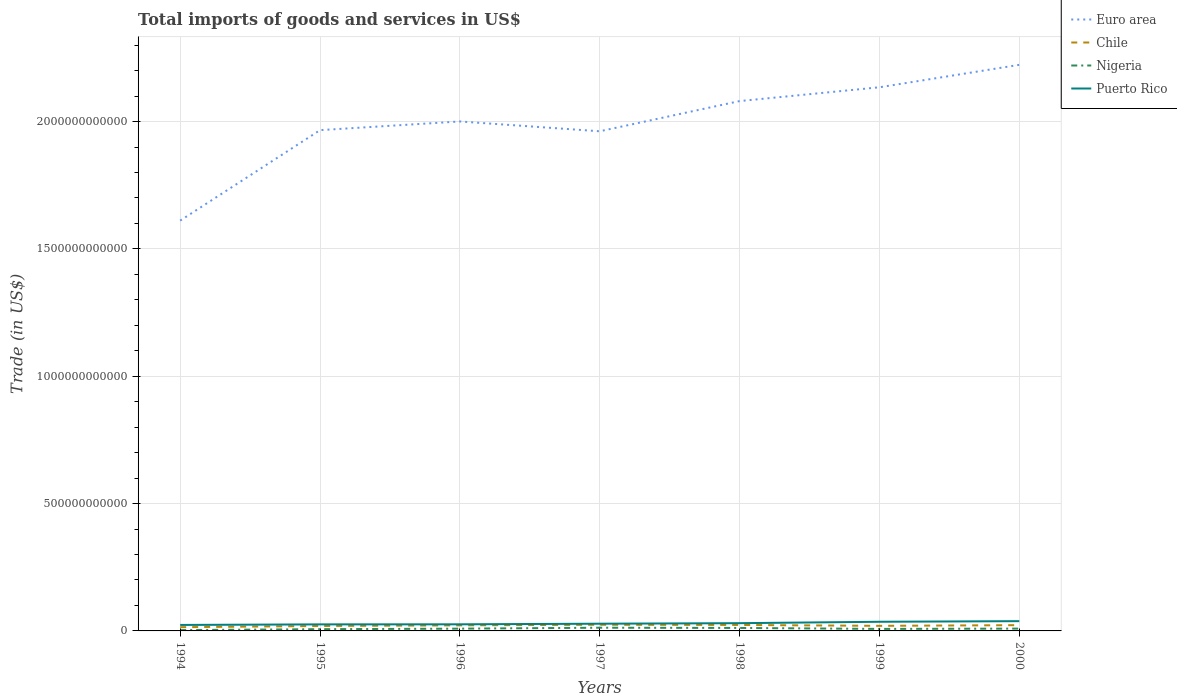Does the line corresponding to Euro area intersect with the line corresponding to Chile?
Ensure brevity in your answer.  No. Is the number of lines equal to the number of legend labels?
Your answer should be very brief. Yes. Across all years, what is the maximum total imports of goods and services in Puerto Rico?
Your answer should be very brief. 2.35e+1. What is the total total imports of goods and services in Nigeria in the graph?
Your answer should be compact. -5.72e+09. What is the difference between the highest and the second highest total imports of goods and services in Nigeria?
Give a very brief answer. 9.31e+09. How many years are there in the graph?
Keep it short and to the point. 7. What is the difference between two consecutive major ticks on the Y-axis?
Offer a very short reply. 5.00e+11. Does the graph contain any zero values?
Provide a succinct answer. No. Where does the legend appear in the graph?
Offer a terse response. Top right. How are the legend labels stacked?
Your answer should be very brief. Vertical. What is the title of the graph?
Offer a terse response. Total imports of goods and services in US$. Does "Uzbekistan" appear as one of the legend labels in the graph?
Offer a terse response. No. What is the label or title of the X-axis?
Ensure brevity in your answer.  Years. What is the label or title of the Y-axis?
Your answer should be very brief. Trade (in US$). What is the Trade (in US$) in Euro area in 1994?
Your response must be concise. 1.61e+12. What is the Trade (in US$) of Chile in 1994?
Give a very brief answer. 1.47e+1. What is the Trade (in US$) of Nigeria in 1994?
Offer a very short reply. 3.26e+09. What is the Trade (in US$) of Puerto Rico in 1994?
Make the answer very short. 2.35e+1. What is the Trade (in US$) in Euro area in 1995?
Offer a very short reply. 1.97e+12. What is the Trade (in US$) of Chile in 1995?
Offer a very short reply. 1.93e+1. What is the Trade (in US$) in Nigeria in 1995?
Provide a short and direct response. 6.85e+09. What is the Trade (in US$) in Puerto Rico in 1995?
Keep it short and to the point. 2.57e+1. What is the Trade (in US$) in Euro area in 1996?
Your response must be concise. 2.00e+12. What is the Trade (in US$) in Chile in 1996?
Keep it short and to the point. 2.19e+1. What is the Trade (in US$) of Nigeria in 1996?
Offer a very short reply. 8.91e+09. What is the Trade (in US$) in Puerto Rico in 1996?
Offer a very short reply. 2.60e+1. What is the Trade (in US$) in Euro area in 1997?
Ensure brevity in your answer.  1.96e+12. What is the Trade (in US$) in Chile in 1997?
Provide a short and direct response. 2.42e+1. What is the Trade (in US$) of Nigeria in 1997?
Your answer should be very brief. 1.26e+1. What is the Trade (in US$) of Puerto Rico in 1997?
Keep it short and to the point. 2.83e+1. What is the Trade (in US$) of Euro area in 1998?
Offer a terse response. 2.08e+12. What is the Trade (in US$) of Chile in 1998?
Make the answer very short. 2.35e+1. What is the Trade (in US$) of Nigeria in 1998?
Offer a very short reply. 1.17e+1. What is the Trade (in US$) of Puerto Rico in 1998?
Your answer should be very brief. 3.04e+1. What is the Trade (in US$) of Euro area in 1999?
Provide a succinct answer. 2.13e+12. What is the Trade (in US$) of Chile in 1999?
Your answer should be very brief. 1.99e+1. What is the Trade (in US$) of Nigeria in 1999?
Your answer should be compact. 7.88e+09. What is the Trade (in US$) of Puerto Rico in 1999?
Ensure brevity in your answer.  3.59e+1. What is the Trade (in US$) of Euro area in 2000?
Your answer should be very brief. 2.22e+12. What is the Trade (in US$) in Chile in 2000?
Provide a succinct answer. 2.27e+1. What is the Trade (in US$) of Nigeria in 2000?
Offer a very short reply. 9.11e+09. What is the Trade (in US$) in Puerto Rico in 2000?
Your answer should be very brief. 3.83e+1. Across all years, what is the maximum Trade (in US$) of Euro area?
Offer a terse response. 2.22e+12. Across all years, what is the maximum Trade (in US$) of Chile?
Your answer should be very brief. 2.42e+1. Across all years, what is the maximum Trade (in US$) in Nigeria?
Make the answer very short. 1.26e+1. Across all years, what is the maximum Trade (in US$) of Puerto Rico?
Your answer should be compact. 3.83e+1. Across all years, what is the minimum Trade (in US$) of Euro area?
Keep it short and to the point. 1.61e+12. Across all years, what is the minimum Trade (in US$) in Chile?
Your answer should be very brief. 1.47e+1. Across all years, what is the minimum Trade (in US$) of Nigeria?
Offer a terse response. 3.26e+09. Across all years, what is the minimum Trade (in US$) in Puerto Rico?
Make the answer very short. 2.35e+1. What is the total Trade (in US$) of Euro area in the graph?
Your answer should be compact. 1.40e+13. What is the total Trade (in US$) in Chile in the graph?
Provide a short and direct response. 1.46e+11. What is the total Trade (in US$) in Nigeria in the graph?
Keep it short and to the point. 6.03e+1. What is the total Trade (in US$) in Puerto Rico in the graph?
Offer a very short reply. 2.08e+11. What is the difference between the Trade (in US$) in Euro area in 1994 and that in 1995?
Provide a succinct answer. -3.55e+11. What is the difference between the Trade (in US$) in Chile in 1994 and that in 1995?
Your answer should be compact. -4.68e+09. What is the difference between the Trade (in US$) in Nigeria in 1994 and that in 1995?
Offer a very short reply. -3.60e+09. What is the difference between the Trade (in US$) in Puerto Rico in 1994 and that in 1995?
Provide a succinct answer. -2.20e+09. What is the difference between the Trade (in US$) in Euro area in 1994 and that in 1996?
Your answer should be compact. -3.89e+11. What is the difference between the Trade (in US$) in Chile in 1994 and that in 1996?
Your answer should be compact. -7.29e+09. What is the difference between the Trade (in US$) in Nigeria in 1994 and that in 1996?
Offer a terse response. -5.65e+09. What is the difference between the Trade (in US$) in Puerto Rico in 1994 and that in 1996?
Ensure brevity in your answer.  -2.47e+09. What is the difference between the Trade (in US$) of Euro area in 1994 and that in 1997?
Give a very brief answer. -3.51e+11. What is the difference between the Trade (in US$) in Chile in 1994 and that in 1997?
Your answer should be very brief. -9.53e+09. What is the difference between the Trade (in US$) of Nigeria in 1994 and that in 1997?
Provide a succinct answer. -9.31e+09. What is the difference between the Trade (in US$) of Puerto Rico in 1994 and that in 1997?
Your answer should be compact. -4.81e+09. What is the difference between the Trade (in US$) of Euro area in 1994 and that in 1998?
Offer a terse response. -4.69e+11. What is the difference between the Trade (in US$) in Chile in 1994 and that in 1998?
Provide a short and direct response. -8.81e+09. What is the difference between the Trade (in US$) of Nigeria in 1994 and that in 1998?
Offer a terse response. -8.42e+09. What is the difference between the Trade (in US$) in Puerto Rico in 1994 and that in 1998?
Your response must be concise. -6.94e+09. What is the difference between the Trade (in US$) of Euro area in 1994 and that in 1999?
Your response must be concise. -5.24e+11. What is the difference between the Trade (in US$) in Chile in 1994 and that in 1999?
Give a very brief answer. -5.29e+09. What is the difference between the Trade (in US$) of Nigeria in 1994 and that in 1999?
Keep it short and to the point. -4.63e+09. What is the difference between the Trade (in US$) of Puerto Rico in 1994 and that in 1999?
Make the answer very short. -1.24e+1. What is the difference between the Trade (in US$) of Euro area in 1994 and that in 2000?
Give a very brief answer. -6.12e+11. What is the difference between the Trade (in US$) of Chile in 1994 and that in 2000?
Make the answer very short. -8.01e+09. What is the difference between the Trade (in US$) in Nigeria in 1994 and that in 2000?
Make the answer very short. -5.86e+09. What is the difference between the Trade (in US$) of Puerto Rico in 1994 and that in 2000?
Your answer should be very brief. -1.48e+1. What is the difference between the Trade (in US$) of Euro area in 1995 and that in 1996?
Your answer should be compact. -3.41e+1. What is the difference between the Trade (in US$) of Chile in 1995 and that in 1996?
Ensure brevity in your answer.  -2.61e+09. What is the difference between the Trade (in US$) in Nigeria in 1995 and that in 1996?
Your answer should be compact. -2.05e+09. What is the difference between the Trade (in US$) of Puerto Rico in 1995 and that in 1996?
Provide a succinct answer. -2.71e+08. What is the difference between the Trade (in US$) in Euro area in 1995 and that in 1997?
Give a very brief answer. 4.49e+09. What is the difference between the Trade (in US$) of Chile in 1995 and that in 1997?
Your answer should be compact. -4.85e+09. What is the difference between the Trade (in US$) of Nigeria in 1995 and that in 1997?
Make the answer very short. -5.72e+09. What is the difference between the Trade (in US$) in Puerto Rico in 1995 and that in 1997?
Your answer should be compact. -2.62e+09. What is the difference between the Trade (in US$) of Euro area in 1995 and that in 1998?
Provide a short and direct response. -1.14e+11. What is the difference between the Trade (in US$) of Chile in 1995 and that in 1998?
Your answer should be compact. -4.13e+09. What is the difference between the Trade (in US$) of Nigeria in 1995 and that in 1998?
Provide a short and direct response. -4.82e+09. What is the difference between the Trade (in US$) of Puerto Rico in 1995 and that in 1998?
Your answer should be very brief. -4.74e+09. What is the difference between the Trade (in US$) of Euro area in 1995 and that in 1999?
Your answer should be very brief. -1.68e+11. What is the difference between the Trade (in US$) in Chile in 1995 and that in 1999?
Offer a very short reply. -6.09e+08. What is the difference between the Trade (in US$) in Nigeria in 1995 and that in 1999?
Make the answer very short. -1.03e+09. What is the difference between the Trade (in US$) of Puerto Rico in 1995 and that in 1999?
Offer a terse response. -1.02e+1. What is the difference between the Trade (in US$) of Euro area in 1995 and that in 2000?
Provide a short and direct response. -2.56e+11. What is the difference between the Trade (in US$) of Chile in 1995 and that in 2000?
Your answer should be very brief. -3.33e+09. What is the difference between the Trade (in US$) in Nigeria in 1995 and that in 2000?
Provide a short and direct response. -2.26e+09. What is the difference between the Trade (in US$) in Puerto Rico in 1995 and that in 2000?
Make the answer very short. -1.26e+1. What is the difference between the Trade (in US$) in Euro area in 1996 and that in 1997?
Provide a succinct answer. 3.86e+1. What is the difference between the Trade (in US$) of Chile in 1996 and that in 1997?
Your answer should be compact. -2.24e+09. What is the difference between the Trade (in US$) in Nigeria in 1996 and that in 1997?
Offer a very short reply. -3.66e+09. What is the difference between the Trade (in US$) in Puerto Rico in 1996 and that in 1997?
Offer a terse response. -2.34e+09. What is the difference between the Trade (in US$) in Euro area in 1996 and that in 1998?
Give a very brief answer. -8.00e+1. What is the difference between the Trade (in US$) of Chile in 1996 and that in 1998?
Ensure brevity in your answer.  -1.52e+09. What is the difference between the Trade (in US$) of Nigeria in 1996 and that in 1998?
Keep it short and to the point. -2.77e+09. What is the difference between the Trade (in US$) of Puerto Rico in 1996 and that in 1998?
Ensure brevity in your answer.  -4.47e+09. What is the difference between the Trade (in US$) in Euro area in 1996 and that in 1999?
Provide a succinct answer. -1.34e+11. What is the difference between the Trade (in US$) of Chile in 1996 and that in 1999?
Your answer should be compact. 2.00e+09. What is the difference between the Trade (in US$) of Nigeria in 1996 and that in 1999?
Your response must be concise. 1.02e+09. What is the difference between the Trade (in US$) in Puerto Rico in 1996 and that in 1999?
Keep it short and to the point. -9.97e+09. What is the difference between the Trade (in US$) in Euro area in 1996 and that in 2000?
Offer a very short reply. -2.22e+11. What is the difference between the Trade (in US$) of Chile in 1996 and that in 2000?
Provide a short and direct response. -7.24e+08. What is the difference between the Trade (in US$) in Nigeria in 1996 and that in 2000?
Your response must be concise. -2.10e+08. What is the difference between the Trade (in US$) of Puerto Rico in 1996 and that in 2000?
Provide a short and direct response. -1.24e+1. What is the difference between the Trade (in US$) in Euro area in 1997 and that in 1998?
Make the answer very short. -1.19e+11. What is the difference between the Trade (in US$) of Chile in 1997 and that in 1998?
Provide a short and direct response. 7.15e+08. What is the difference between the Trade (in US$) of Nigeria in 1997 and that in 1998?
Keep it short and to the point. 8.93e+08. What is the difference between the Trade (in US$) in Puerto Rico in 1997 and that in 1998?
Offer a terse response. -2.12e+09. What is the difference between the Trade (in US$) of Euro area in 1997 and that in 1999?
Make the answer very short. -1.73e+11. What is the difference between the Trade (in US$) in Chile in 1997 and that in 1999?
Provide a succinct answer. 4.24e+09. What is the difference between the Trade (in US$) of Nigeria in 1997 and that in 1999?
Your answer should be very brief. 4.69e+09. What is the difference between the Trade (in US$) of Puerto Rico in 1997 and that in 1999?
Your answer should be very brief. -7.63e+09. What is the difference between the Trade (in US$) in Euro area in 1997 and that in 2000?
Provide a short and direct response. -2.61e+11. What is the difference between the Trade (in US$) of Chile in 1997 and that in 2000?
Your answer should be very brief. 1.51e+09. What is the difference between the Trade (in US$) of Nigeria in 1997 and that in 2000?
Your answer should be very brief. 3.45e+09. What is the difference between the Trade (in US$) in Puerto Rico in 1997 and that in 2000?
Your response must be concise. -1.00e+1. What is the difference between the Trade (in US$) in Euro area in 1998 and that in 1999?
Give a very brief answer. -5.42e+1. What is the difference between the Trade (in US$) in Chile in 1998 and that in 1999?
Give a very brief answer. 3.52e+09. What is the difference between the Trade (in US$) in Nigeria in 1998 and that in 1999?
Your answer should be compact. 3.79e+09. What is the difference between the Trade (in US$) in Puerto Rico in 1998 and that in 1999?
Your answer should be compact. -5.50e+09. What is the difference between the Trade (in US$) in Euro area in 1998 and that in 2000?
Offer a terse response. -1.42e+11. What is the difference between the Trade (in US$) in Chile in 1998 and that in 2000?
Make the answer very short. 7.97e+08. What is the difference between the Trade (in US$) in Nigeria in 1998 and that in 2000?
Your response must be concise. 2.56e+09. What is the difference between the Trade (in US$) of Puerto Rico in 1998 and that in 2000?
Offer a terse response. -7.90e+09. What is the difference between the Trade (in US$) of Euro area in 1999 and that in 2000?
Your answer should be very brief. -8.81e+1. What is the difference between the Trade (in US$) of Chile in 1999 and that in 2000?
Provide a short and direct response. -2.72e+09. What is the difference between the Trade (in US$) of Nigeria in 1999 and that in 2000?
Your answer should be compact. -1.23e+09. What is the difference between the Trade (in US$) in Puerto Rico in 1999 and that in 2000?
Your response must be concise. -2.40e+09. What is the difference between the Trade (in US$) in Euro area in 1994 and the Trade (in US$) in Chile in 1995?
Provide a succinct answer. 1.59e+12. What is the difference between the Trade (in US$) in Euro area in 1994 and the Trade (in US$) in Nigeria in 1995?
Offer a very short reply. 1.60e+12. What is the difference between the Trade (in US$) of Euro area in 1994 and the Trade (in US$) of Puerto Rico in 1995?
Keep it short and to the point. 1.59e+12. What is the difference between the Trade (in US$) of Chile in 1994 and the Trade (in US$) of Nigeria in 1995?
Offer a terse response. 7.80e+09. What is the difference between the Trade (in US$) of Chile in 1994 and the Trade (in US$) of Puerto Rico in 1995?
Offer a very short reply. -1.10e+1. What is the difference between the Trade (in US$) of Nigeria in 1994 and the Trade (in US$) of Puerto Rico in 1995?
Your response must be concise. -2.24e+1. What is the difference between the Trade (in US$) in Euro area in 1994 and the Trade (in US$) in Chile in 1996?
Your answer should be very brief. 1.59e+12. What is the difference between the Trade (in US$) of Euro area in 1994 and the Trade (in US$) of Nigeria in 1996?
Provide a succinct answer. 1.60e+12. What is the difference between the Trade (in US$) of Euro area in 1994 and the Trade (in US$) of Puerto Rico in 1996?
Your answer should be very brief. 1.59e+12. What is the difference between the Trade (in US$) in Chile in 1994 and the Trade (in US$) in Nigeria in 1996?
Ensure brevity in your answer.  5.75e+09. What is the difference between the Trade (in US$) of Chile in 1994 and the Trade (in US$) of Puerto Rico in 1996?
Your response must be concise. -1.13e+1. What is the difference between the Trade (in US$) of Nigeria in 1994 and the Trade (in US$) of Puerto Rico in 1996?
Your answer should be compact. -2.27e+1. What is the difference between the Trade (in US$) in Euro area in 1994 and the Trade (in US$) in Chile in 1997?
Your answer should be very brief. 1.59e+12. What is the difference between the Trade (in US$) of Euro area in 1994 and the Trade (in US$) of Nigeria in 1997?
Provide a succinct answer. 1.60e+12. What is the difference between the Trade (in US$) of Euro area in 1994 and the Trade (in US$) of Puerto Rico in 1997?
Your answer should be very brief. 1.58e+12. What is the difference between the Trade (in US$) in Chile in 1994 and the Trade (in US$) in Nigeria in 1997?
Provide a short and direct response. 2.09e+09. What is the difference between the Trade (in US$) in Chile in 1994 and the Trade (in US$) in Puerto Rico in 1997?
Your response must be concise. -1.37e+1. What is the difference between the Trade (in US$) of Nigeria in 1994 and the Trade (in US$) of Puerto Rico in 1997?
Provide a succinct answer. -2.51e+1. What is the difference between the Trade (in US$) of Euro area in 1994 and the Trade (in US$) of Chile in 1998?
Offer a very short reply. 1.59e+12. What is the difference between the Trade (in US$) in Euro area in 1994 and the Trade (in US$) in Nigeria in 1998?
Provide a short and direct response. 1.60e+12. What is the difference between the Trade (in US$) of Euro area in 1994 and the Trade (in US$) of Puerto Rico in 1998?
Offer a terse response. 1.58e+12. What is the difference between the Trade (in US$) in Chile in 1994 and the Trade (in US$) in Nigeria in 1998?
Offer a terse response. 2.98e+09. What is the difference between the Trade (in US$) in Chile in 1994 and the Trade (in US$) in Puerto Rico in 1998?
Make the answer very short. -1.58e+1. What is the difference between the Trade (in US$) in Nigeria in 1994 and the Trade (in US$) in Puerto Rico in 1998?
Make the answer very short. -2.72e+1. What is the difference between the Trade (in US$) of Euro area in 1994 and the Trade (in US$) of Chile in 1999?
Your answer should be compact. 1.59e+12. What is the difference between the Trade (in US$) of Euro area in 1994 and the Trade (in US$) of Nigeria in 1999?
Make the answer very short. 1.60e+12. What is the difference between the Trade (in US$) of Euro area in 1994 and the Trade (in US$) of Puerto Rico in 1999?
Make the answer very short. 1.58e+12. What is the difference between the Trade (in US$) in Chile in 1994 and the Trade (in US$) in Nigeria in 1999?
Provide a short and direct response. 6.77e+09. What is the difference between the Trade (in US$) of Chile in 1994 and the Trade (in US$) of Puerto Rico in 1999?
Provide a succinct answer. -2.13e+1. What is the difference between the Trade (in US$) of Nigeria in 1994 and the Trade (in US$) of Puerto Rico in 1999?
Offer a terse response. -3.27e+1. What is the difference between the Trade (in US$) of Euro area in 1994 and the Trade (in US$) of Chile in 2000?
Provide a short and direct response. 1.59e+12. What is the difference between the Trade (in US$) in Euro area in 1994 and the Trade (in US$) in Nigeria in 2000?
Offer a very short reply. 1.60e+12. What is the difference between the Trade (in US$) of Euro area in 1994 and the Trade (in US$) of Puerto Rico in 2000?
Offer a very short reply. 1.57e+12. What is the difference between the Trade (in US$) of Chile in 1994 and the Trade (in US$) of Nigeria in 2000?
Your answer should be very brief. 5.54e+09. What is the difference between the Trade (in US$) in Chile in 1994 and the Trade (in US$) in Puerto Rico in 2000?
Give a very brief answer. -2.37e+1. What is the difference between the Trade (in US$) of Nigeria in 1994 and the Trade (in US$) of Puerto Rico in 2000?
Your answer should be very brief. -3.51e+1. What is the difference between the Trade (in US$) in Euro area in 1995 and the Trade (in US$) in Chile in 1996?
Make the answer very short. 1.94e+12. What is the difference between the Trade (in US$) in Euro area in 1995 and the Trade (in US$) in Nigeria in 1996?
Your answer should be compact. 1.96e+12. What is the difference between the Trade (in US$) of Euro area in 1995 and the Trade (in US$) of Puerto Rico in 1996?
Keep it short and to the point. 1.94e+12. What is the difference between the Trade (in US$) of Chile in 1995 and the Trade (in US$) of Nigeria in 1996?
Ensure brevity in your answer.  1.04e+1. What is the difference between the Trade (in US$) of Chile in 1995 and the Trade (in US$) of Puerto Rico in 1996?
Keep it short and to the point. -6.64e+09. What is the difference between the Trade (in US$) in Nigeria in 1995 and the Trade (in US$) in Puerto Rico in 1996?
Make the answer very short. -1.91e+1. What is the difference between the Trade (in US$) of Euro area in 1995 and the Trade (in US$) of Chile in 1997?
Your answer should be compact. 1.94e+12. What is the difference between the Trade (in US$) in Euro area in 1995 and the Trade (in US$) in Nigeria in 1997?
Your answer should be compact. 1.95e+12. What is the difference between the Trade (in US$) of Euro area in 1995 and the Trade (in US$) of Puerto Rico in 1997?
Offer a very short reply. 1.94e+12. What is the difference between the Trade (in US$) in Chile in 1995 and the Trade (in US$) in Nigeria in 1997?
Provide a succinct answer. 6.77e+09. What is the difference between the Trade (in US$) of Chile in 1995 and the Trade (in US$) of Puerto Rico in 1997?
Make the answer very short. -8.98e+09. What is the difference between the Trade (in US$) of Nigeria in 1995 and the Trade (in US$) of Puerto Rico in 1997?
Your response must be concise. -2.15e+1. What is the difference between the Trade (in US$) in Euro area in 1995 and the Trade (in US$) in Chile in 1998?
Offer a very short reply. 1.94e+12. What is the difference between the Trade (in US$) of Euro area in 1995 and the Trade (in US$) of Nigeria in 1998?
Give a very brief answer. 1.95e+12. What is the difference between the Trade (in US$) in Euro area in 1995 and the Trade (in US$) in Puerto Rico in 1998?
Give a very brief answer. 1.94e+12. What is the difference between the Trade (in US$) of Chile in 1995 and the Trade (in US$) of Nigeria in 1998?
Make the answer very short. 7.66e+09. What is the difference between the Trade (in US$) of Chile in 1995 and the Trade (in US$) of Puerto Rico in 1998?
Offer a very short reply. -1.11e+1. What is the difference between the Trade (in US$) in Nigeria in 1995 and the Trade (in US$) in Puerto Rico in 1998?
Give a very brief answer. -2.36e+1. What is the difference between the Trade (in US$) in Euro area in 1995 and the Trade (in US$) in Chile in 1999?
Provide a short and direct response. 1.95e+12. What is the difference between the Trade (in US$) in Euro area in 1995 and the Trade (in US$) in Nigeria in 1999?
Your answer should be very brief. 1.96e+12. What is the difference between the Trade (in US$) in Euro area in 1995 and the Trade (in US$) in Puerto Rico in 1999?
Provide a succinct answer. 1.93e+12. What is the difference between the Trade (in US$) in Chile in 1995 and the Trade (in US$) in Nigeria in 1999?
Make the answer very short. 1.15e+1. What is the difference between the Trade (in US$) of Chile in 1995 and the Trade (in US$) of Puerto Rico in 1999?
Give a very brief answer. -1.66e+1. What is the difference between the Trade (in US$) in Nigeria in 1995 and the Trade (in US$) in Puerto Rico in 1999?
Your response must be concise. -2.91e+1. What is the difference between the Trade (in US$) of Euro area in 1995 and the Trade (in US$) of Chile in 2000?
Give a very brief answer. 1.94e+12. What is the difference between the Trade (in US$) of Euro area in 1995 and the Trade (in US$) of Nigeria in 2000?
Ensure brevity in your answer.  1.96e+12. What is the difference between the Trade (in US$) in Euro area in 1995 and the Trade (in US$) in Puerto Rico in 2000?
Keep it short and to the point. 1.93e+12. What is the difference between the Trade (in US$) of Chile in 1995 and the Trade (in US$) of Nigeria in 2000?
Give a very brief answer. 1.02e+1. What is the difference between the Trade (in US$) in Chile in 1995 and the Trade (in US$) in Puerto Rico in 2000?
Your answer should be very brief. -1.90e+1. What is the difference between the Trade (in US$) of Nigeria in 1995 and the Trade (in US$) of Puerto Rico in 2000?
Keep it short and to the point. -3.15e+1. What is the difference between the Trade (in US$) in Euro area in 1996 and the Trade (in US$) in Chile in 1997?
Your answer should be very brief. 1.98e+12. What is the difference between the Trade (in US$) in Euro area in 1996 and the Trade (in US$) in Nigeria in 1997?
Provide a short and direct response. 1.99e+12. What is the difference between the Trade (in US$) in Euro area in 1996 and the Trade (in US$) in Puerto Rico in 1997?
Provide a succinct answer. 1.97e+12. What is the difference between the Trade (in US$) in Chile in 1996 and the Trade (in US$) in Nigeria in 1997?
Offer a terse response. 9.38e+09. What is the difference between the Trade (in US$) of Chile in 1996 and the Trade (in US$) of Puerto Rico in 1997?
Ensure brevity in your answer.  -6.37e+09. What is the difference between the Trade (in US$) in Nigeria in 1996 and the Trade (in US$) in Puerto Rico in 1997?
Make the answer very short. -1.94e+1. What is the difference between the Trade (in US$) in Euro area in 1996 and the Trade (in US$) in Chile in 1998?
Your answer should be compact. 1.98e+12. What is the difference between the Trade (in US$) of Euro area in 1996 and the Trade (in US$) of Nigeria in 1998?
Your answer should be very brief. 1.99e+12. What is the difference between the Trade (in US$) of Euro area in 1996 and the Trade (in US$) of Puerto Rico in 1998?
Your answer should be compact. 1.97e+12. What is the difference between the Trade (in US$) in Chile in 1996 and the Trade (in US$) in Nigeria in 1998?
Provide a succinct answer. 1.03e+1. What is the difference between the Trade (in US$) in Chile in 1996 and the Trade (in US$) in Puerto Rico in 1998?
Provide a succinct answer. -8.50e+09. What is the difference between the Trade (in US$) of Nigeria in 1996 and the Trade (in US$) of Puerto Rico in 1998?
Offer a terse response. -2.15e+1. What is the difference between the Trade (in US$) of Euro area in 1996 and the Trade (in US$) of Chile in 1999?
Offer a very short reply. 1.98e+12. What is the difference between the Trade (in US$) of Euro area in 1996 and the Trade (in US$) of Nigeria in 1999?
Provide a short and direct response. 1.99e+12. What is the difference between the Trade (in US$) in Euro area in 1996 and the Trade (in US$) in Puerto Rico in 1999?
Ensure brevity in your answer.  1.96e+12. What is the difference between the Trade (in US$) in Chile in 1996 and the Trade (in US$) in Nigeria in 1999?
Provide a succinct answer. 1.41e+1. What is the difference between the Trade (in US$) in Chile in 1996 and the Trade (in US$) in Puerto Rico in 1999?
Offer a terse response. -1.40e+1. What is the difference between the Trade (in US$) in Nigeria in 1996 and the Trade (in US$) in Puerto Rico in 1999?
Your answer should be very brief. -2.70e+1. What is the difference between the Trade (in US$) in Euro area in 1996 and the Trade (in US$) in Chile in 2000?
Provide a succinct answer. 1.98e+12. What is the difference between the Trade (in US$) in Euro area in 1996 and the Trade (in US$) in Nigeria in 2000?
Provide a short and direct response. 1.99e+12. What is the difference between the Trade (in US$) in Euro area in 1996 and the Trade (in US$) in Puerto Rico in 2000?
Provide a succinct answer. 1.96e+12. What is the difference between the Trade (in US$) of Chile in 1996 and the Trade (in US$) of Nigeria in 2000?
Ensure brevity in your answer.  1.28e+1. What is the difference between the Trade (in US$) of Chile in 1996 and the Trade (in US$) of Puerto Rico in 2000?
Ensure brevity in your answer.  -1.64e+1. What is the difference between the Trade (in US$) of Nigeria in 1996 and the Trade (in US$) of Puerto Rico in 2000?
Ensure brevity in your answer.  -2.94e+1. What is the difference between the Trade (in US$) of Euro area in 1997 and the Trade (in US$) of Chile in 1998?
Provide a short and direct response. 1.94e+12. What is the difference between the Trade (in US$) of Euro area in 1997 and the Trade (in US$) of Nigeria in 1998?
Make the answer very short. 1.95e+12. What is the difference between the Trade (in US$) in Euro area in 1997 and the Trade (in US$) in Puerto Rico in 1998?
Ensure brevity in your answer.  1.93e+12. What is the difference between the Trade (in US$) in Chile in 1997 and the Trade (in US$) in Nigeria in 1998?
Your response must be concise. 1.25e+1. What is the difference between the Trade (in US$) in Chile in 1997 and the Trade (in US$) in Puerto Rico in 1998?
Give a very brief answer. -6.26e+09. What is the difference between the Trade (in US$) in Nigeria in 1997 and the Trade (in US$) in Puerto Rico in 1998?
Make the answer very short. -1.79e+1. What is the difference between the Trade (in US$) of Euro area in 1997 and the Trade (in US$) of Chile in 1999?
Offer a very short reply. 1.94e+12. What is the difference between the Trade (in US$) in Euro area in 1997 and the Trade (in US$) in Nigeria in 1999?
Offer a terse response. 1.95e+12. What is the difference between the Trade (in US$) of Euro area in 1997 and the Trade (in US$) of Puerto Rico in 1999?
Provide a succinct answer. 1.93e+12. What is the difference between the Trade (in US$) of Chile in 1997 and the Trade (in US$) of Nigeria in 1999?
Provide a succinct answer. 1.63e+1. What is the difference between the Trade (in US$) of Chile in 1997 and the Trade (in US$) of Puerto Rico in 1999?
Provide a succinct answer. -1.18e+1. What is the difference between the Trade (in US$) in Nigeria in 1997 and the Trade (in US$) in Puerto Rico in 1999?
Offer a very short reply. -2.34e+1. What is the difference between the Trade (in US$) in Euro area in 1997 and the Trade (in US$) in Chile in 2000?
Your response must be concise. 1.94e+12. What is the difference between the Trade (in US$) of Euro area in 1997 and the Trade (in US$) of Nigeria in 2000?
Make the answer very short. 1.95e+12. What is the difference between the Trade (in US$) in Euro area in 1997 and the Trade (in US$) in Puerto Rico in 2000?
Keep it short and to the point. 1.92e+12. What is the difference between the Trade (in US$) of Chile in 1997 and the Trade (in US$) of Nigeria in 2000?
Keep it short and to the point. 1.51e+1. What is the difference between the Trade (in US$) in Chile in 1997 and the Trade (in US$) in Puerto Rico in 2000?
Keep it short and to the point. -1.42e+1. What is the difference between the Trade (in US$) in Nigeria in 1997 and the Trade (in US$) in Puerto Rico in 2000?
Make the answer very short. -2.58e+1. What is the difference between the Trade (in US$) in Euro area in 1998 and the Trade (in US$) in Chile in 1999?
Ensure brevity in your answer.  2.06e+12. What is the difference between the Trade (in US$) in Euro area in 1998 and the Trade (in US$) in Nigeria in 1999?
Provide a succinct answer. 2.07e+12. What is the difference between the Trade (in US$) of Euro area in 1998 and the Trade (in US$) of Puerto Rico in 1999?
Your response must be concise. 2.04e+12. What is the difference between the Trade (in US$) of Chile in 1998 and the Trade (in US$) of Nigeria in 1999?
Offer a terse response. 1.56e+1. What is the difference between the Trade (in US$) in Chile in 1998 and the Trade (in US$) in Puerto Rico in 1999?
Give a very brief answer. -1.25e+1. What is the difference between the Trade (in US$) of Nigeria in 1998 and the Trade (in US$) of Puerto Rico in 1999?
Ensure brevity in your answer.  -2.43e+1. What is the difference between the Trade (in US$) of Euro area in 1998 and the Trade (in US$) of Chile in 2000?
Ensure brevity in your answer.  2.06e+12. What is the difference between the Trade (in US$) of Euro area in 1998 and the Trade (in US$) of Nigeria in 2000?
Make the answer very short. 2.07e+12. What is the difference between the Trade (in US$) in Euro area in 1998 and the Trade (in US$) in Puerto Rico in 2000?
Ensure brevity in your answer.  2.04e+12. What is the difference between the Trade (in US$) of Chile in 1998 and the Trade (in US$) of Nigeria in 2000?
Keep it short and to the point. 1.44e+1. What is the difference between the Trade (in US$) of Chile in 1998 and the Trade (in US$) of Puerto Rico in 2000?
Ensure brevity in your answer.  -1.49e+1. What is the difference between the Trade (in US$) in Nigeria in 1998 and the Trade (in US$) in Puerto Rico in 2000?
Make the answer very short. -2.67e+1. What is the difference between the Trade (in US$) in Euro area in 1999 and the Trade (in US$) in Chile in 2000?
Your response must be concise. 2.11e+12. What is the difference between the Trade (in US$) of Euro area in 1999 and the Trade (in US$) of Nigeria in 2000?
Your answer should be very brief. 2.13e+12. What is the difference between the Trade (in US$) of Euro area in 1999 and the Trade (in US$) of Puerto Rico in 2000?
Make the answer very short. 2.10e+12. What is the difference between the Trade (in US$) in Chile in 1999 and the Trade (in US$) in Nigeria in 2000?
Make the answer very short. 1.08e+1. What is the difference between the Trade (in US$) of Chile in 1999 and the Trade (in US$) of Puerto Rico in 2000?
Offer a terse response. -1.84e+1. What is the difference between the Trade (in US$) in Nigeria in 1999 and the Trade (in US$) in Puerto Rico in 2000?
Provide a short and direct response. -3.05e+1. What is the average Trade (in US$) in Euro area per year?
Your answer should be very brief. 2.00e+12. What is the average Trade (in US$) of Chile per year?
Your answer should be compact. 2.09e+1. What is the average Trade (in US$) in Nigeria per year?
Your answer should be very brief. 8.61e+09. What is the average Trade (in US$) in Puerto Rico per year?
Your answer should be very brief. 2.97e+1. In the year 1994, what is the difference between the Trade (in US$) in Euro area and Trade (in US$) in Chile?
Offer a terse response. 1.60e+12. In the year 1994, what is the difference between the Trade (in US$) in Euro area and Trade (in US$) in Nigeria?
Your answer should be very brief. 1.61e+12. In the year 1994, what is the difference between the Trade (in US$) of Euro area and Trade (in US$) of Puerto Rico?
Ensure brevity in your answer.  1.59e+12. In the year 1994, what is the difference between the Trade (in US$) of Chile and Trade (in US$) of Nigeria?
Provide a succinct answer. 1.14e+1. In the year 1994, what is the difference between the Trade (in US$) in Chile and Trade (in US$) in Puerto Rico?
Make the answer very short. -8.85e+09. In the year 1994, what is the difference between the Trade (in US$) in Nigeria and Trade (in US$) in Puerto Rico?
Give a very brief answer. -2.03e+1. In the year 1995, what is the difference between the Trade (in US$) in Euro area and Trade (in US$) in Chile?
Your response must be concise. 1.95e+12. In the year 1995, what is the difference between the Trade (in US$) in Euro area and Trade (in US$) in Nigeria?
Provide a succinct answer. 1.96e+12. In the year 1995, what is the difference between the Trade (in US$) of Euro area and Trade (in US$) of Puerto Rico?
Provide a short and direct response. 1.94e+12. In the year 1995, what is the difference between the Trade (in US$) of Chile and Trade (in US$) of Nigeria?
Make the answer very short. 1.25e+1. In the year 1995, what is the difference between the Trade (in US$) in Chile and Trade (in US$) in Puerto Rico?
Provide a short and direct response. -6.37e+09. In the year 1995, what is the difference between the Trade (in US$) in Nigeria and Trade (in US$) in Puerto Rico?
Give a very brief answer. -1.89e+1. In the year 1996, what is the difference between the Trade (in US$) in Euro area and Trade (in US$) in Chile?
Provide a short and direct response. 1.98e+12. In the year 1996, what is the difference between the Trade (in US$) of Euro area and Trade (in US$) of Nigeria?
Provide a short and direct response. 1.99e+12. In the year 1996, what is the difference between the Trade (in US$) of Euro area and Trade (in US$) of Puerto Rico?
Offer a very short reply. 1.97e+12. In the year 1996, what is the difference between the Trade (in US$) in Chile and Trade (in US$) in Nigeria?
Your answer should be very brief. 1.30e+1. In the year 1996, what is the difference between the Trade (in US$) of Chile and Trade (in US$) of Puerto Rico?
Make the answer very short. -4.03e+09. In the year 1996, what is the difference between the Trade (in US$) in Nigeria and Trade (in US$) in Puerto Rico?
Your answer should be very brief. -1.71e+1. In the year 1997, what is the difference between the Trade (in US$) in Euro area and Trade (in US$) in Chile?
Make the answer very short. 1.94e+12. In the year 1997, what is the difference between the Trade (in US$) of Euro area and Trade (in US$) of Nigeria?
Provide a succinct answer. 1.95e+12. In the year 1997, what is the difference between the Trade (in US$) of Euro area and Trade (in US$) of Puerto Rico?
Provide a short and direct response. 1.93e+12. In the year 1997, what is the difference between the Trade (in US$) of Chile and Trade (in US$) of Nigeria?
Offer a very short reply. 1.16e+1. In the year 1997, what is the difference between the Trade (in US$) of Chile and Trade (in US$) of Puerto Rico?
Ensure brevity in your answer.  -4.14e+09. In the year 1997, what is the difference between the Trade (in US$) in Nigeria and Trade (in US$) in Puerto Rico?
Ensure brevity in your answer.  -1.58e+1. In the year 1998, what is the difference between the Trade (in US$) of Euro area and Trade (in US$) of Chile?
Your response must be concise. 2.06e+12. In the year 1998, what is the difference between the Trade (in US$) of Euro area and Trade (in US$) of Nigeria?
Give a very brief answer. 2.07e+12. In the year 1998, what is the difference between the Trade (in US$) in Euro area and Trade (in US$) in Puerto Rico?
Give a very brief answer. 2.05e+12. In the year 1998, what is the difference between the Trade (in US$) of Chile and Trade (in US$) of Nigeria?
Provide a short and direct response. 1.18e+1. In the year 1998, what is the difference between the Trade (in US$) of Chile and Trade (in US$) of Puerto Rico?
Keep it short and to the point. -6.98e+09. In the year 1998, what is the difference between the Trade (in US$) in Nigeria and Trade (in US$) in Puerto Rico?
Make the answer very short. -1.88e+1. In the year 1999, what is the difference between the Trade (in US$) of Euro area and Trade (in US$) of Chile?
Give a very brief answer. 2.11e+12. In the year 1999, what is the difference between the Trade (in US$) of Euro area and Trade (in US$) of Nigeria?
Provide a succinct answer. 2.13e+12. In the year 1999, what is the difference between the Trade (in US$) in Euro area and Trade (in US$) in Puerto Rico?
Make the answer very short. 2.10e+12. In the year 1999, what is the difference between the Trade (in US$) in Chile and Trade (in US$) in Nigeria?
Offer a very short reply. 1.21e+1. In the year 1999, what is the difference between the Trade (in US$) in Chile and Trade (in US$) in Puerto Rico?
Offer a very short reply. -1.60e+1. In the year 1999, what is the difference between the Trade (in US$) of Nigeria and Trade (in US$) of Puerto Rico?
Keep it short and to the point. -2.81e+1. In the year 2000, what is the difference between the Trade (in US$) in Euro area and Trade (in US$) in Chile?
Ensure brevity in your answer.  2.20e+12. In the year 2000, what is the difference between the Trade (in US$) in Euro area and Trade (in US$) in Nigeria?
Your answer should be compact. 2.21e+12. In the year 2000, what is the difference between the Trade (in US$) of Euro area and Trade (in US$) of Puerto Rico?
Give a very brief answer. 2.18e+12. In the year 2000, what is the difference between the Trade (in US$) in Chile and Trade (in US$) in Nigeria?
Provide a short and direct response. 1.36e+1. In the year 2000, what is the difference between the Trade (in US$) in Chile and Trade (in US$) in Puerto Rico?
Provide a short and direct response. -1.57e+1. In the year 2000, what is the difference between the Trade (in US$) in Nigeria and Trade (in US$) in Puerto Rico?
Ensure brevity in your answer.  -2.92e+1. What is the ratio of the Trade (in US$) in Euro area in 1994 to that in 1995?
Give a very brief answer. 0.82. What is the ratio of the Trade (in US$) in Chile in 1994 to that in 1995?
Provide a short and direct response. 0.76. What is the ratio of the Trade (in US$) in Nigeria in 1994 to that in 1995?
Ensure brevity in your answer.  0.47. What is the ratio of the Trade (in US$) in Puerto Rico in 1994 to that in 1995?
Offer a terse response. 0.91. What is the ratio of the Trade (in US$) of Euro area in 1994 to that in 1996?
Keep it short and to the point. 0.81. What is the ratio of the Trade (in US$) in Chile in 1994 to that in 1996?
Keep it short and to the point. 0.67. What is the ratio of the Trade (in US$) in Nigeria in 1994 to that in 1996?
Your response must be concise. 0.37. What is the ratio of the Trade (in US$) in Puerto Rico in 1994 to that in 1996?
Ensure brevity in your answer.  0.91. What is the ratio of the Trade (in US$) in Euro area in 1994 to that in 1997?
Your answer should be very brief. 0.82. What is the ratio of the Trade (in US$) of Chile in 1994 to that in 1997?
Provide a succinct answer. 0.61. What is the ratio of the Trade (in US$) of Nigeria in 1994 to that in 1997?
Make the answer very short. 0.26. What is the ratio of the Trade (in US$) of Puerto Rico in 1994 to that in 1997?
Provide a short and direct response. 0.83. What is the ratio of the Trade (in US$) of Euro area in 1994 to that in 1998?
Your response must be concise. 0.77. What is the ratio of the Trade (in US$) in Chile in 1994 to that in 1998?
Offer a terse response. 0.62. What is the ratio of the Trade (in US$) of Nigeria in 1994 to that in 1998?
Your response must be concise. 0.28. What is the ratio of the Trade (in US$) in Puerto Rico in 1994 to that in 1998?
Give a very brief answer. 0.77. What is the ratio of the Trade (in US$) in Euro area in 1994 to that in 1999?
Keep it short and to the point. 0.75. What is the ratio of the Trade (in US$) in Chile in 1994 to that in 1999?
Ensure brevity in your answer.  0.73. What is the ratio of the Trade (in US$) of Nigeria in 1994 to that in 1999?
Offer a terse response. 0.41. What is the ratio of the Trade (in US$) of Puerto Rico in 1994 to that in 1999?
Provide a succinct answer. 0.65. What is the ratio of the Trade (in US$) in Euro area in 1994 to that in 2000?
Your response must be concise. 0.72. What is the ratio of the Trade (in US$) of Chile in 1994 to that in 2000?
Provide a succinct answer. 0.65. What is the ratio of the Trade (in US$) in Nigeria in 1994 to that in 2000?
Provide a succinct answer. 0.36. What is the ratio of the Trade (in US$) of Puerto Rico in 1994 to that in 2000?
Provide a succinct answer. 0.61. What is the ratio of the Trade (in US$) in Chile in 1995 to that in 1996?
Provide a short and direct response. 0.88. What is the ratio of the Trade (in US$) of Nigeria in 1995 to that in 1996?
Keep it short and to the point. 0.77. What is the ratio of the Trade (in US$) of Euro area in 1995 to that in 1997?
Make the answer very short. 1. What is the ratio of the Trade (in US$) of Chile in 1995 to that in 1997?
Keep it short and to the point. 0.8. What is the ratio of the Trade (in US$) of Nigeria in 1995 to that in 1997?
Provide a succinct answer. 0.55. What is the ratio of the Trade (in US$) of Puerto Rico in 1995 to that in 1997?
Ensure brevity in your answer.  0.91. What is the ratio of the Trade (in US$) of Euro area in 1995 to that in 1998?
Your answer should be compact. 0.95. What is the ratio of the Trade (in US$) in Chile in 1995 to that in 1998?
Your answer should be very brief. 0.82. What is the ratio of the Trade (in US$) of Nigeria in 1995 to that in 1998?
Make the answer very short. 0.59. What is the ratio of the Trade (in US$) in Puerto Rico in 1995 to that in 1998?
Your answer should be very brief. 0.84. What is the ratio of the Trade (in US$) of Euro area in 1995 to that in 1999?
Offer a very short reply. 0.92. What is the ratio of the Trade (in US$) in Chile in 1995 to that in 1999?
Give a very brief answer. 0.97. What is the ratio of the Trade (in US$) in Nigeria in 1995 to that in 1999?
Keep it short and to the point. 0.87. What is the ratio of the Trade (in US$) in Puerto Rico in 1995 to that in 1999?
Keep it short and to the point. 0.72. What is the ratio of the Trade (in US$) of Euro area in 1995 to that in 2000?
Ensure brevity in your answer.  0.88. What is the ratio of the Trade (in US$) in Chile in 1995 to that in 2000?
Provide a short and direct response. 0.85. What is the ratio of the Trade (in US$) of Nigeria in 1995 to that in 2000?
Offer a very short reply. 0.75. What is the ratio of the Trade (in US$) in Puerto Rico in 1995 to that in 2000?
Your response must be concise. 0.67. What is the ratio of the Trade (in US$) of Euro area in 1996 to that in 1997?
Provide a short and direct response. 1.02. What is the ratio of the Trade (in US$) of Chile in 1996 to that in 1997?
Offer a very short reply. 0.91. What is the ratio of the Trade (in US$) of Nigeria in 1996 to that in 1997?
Give a very brief answer. 0.71. What is the ratio of the Trade (in US$) of Puerto Rico in 1996 to that in 1997?
Provide a succinct answer. 0.92. What is the ratio of the Trade (in US$) in Euro area in 1996 to that in 1998?
Keep it short and to the point. 0.96. What is the ratio of the Trade (in US$) in Chile in 1996 to that in 1998?
Your response must be concise. 0.94. What is the ratio of the Trade (in US$) in Nigeria in 1996 to that in 1998?
Your answer should be compact. 0.76. What is the ratio of the Trade (in US$) in Puerto Rico in 1996 to that in 1998?
Keep it short and to the point. 0.85. What is the ratio of the Trade (in US$) of Euro area in 1996 to that in 1999?
Provide a succinct answer. 0.94. What is the ratio of the Trade (in US$) of Chile in 1996 to that in 1999?
Your answer should be compact. 1.1. What is the ratio of the Trade (in US$) of Nigeria in 1996 to that in 1999?
Your answer should be compact. 1.13. What is the ratio of the Trade (in US$) of Puerto Rico in 1996 to that in 1999?
Offer a terse response. 0.72. What is the ratio of the Trade (in US$) in Chile in 1996 to that in 2000?
Make the answer very short. 0.97. What is the ratio of the Trade (in US$) in Puerto Rico in 1996 to that in 2000?
Offer a terse response. 0.68. What is the ratio of the Trade (in US$) of Euro area in 1997 to that in 1998?
Offer a terse response. 0.94. What is the ratio of the Trade (in US$) of Chile in 1997 to that in 1998?
Your answer should be compact. 1.03. What is the ratio of the Trade (in US$) in Nigeria in 1997 to that in 1998?
Offer a very short reply. 1.08. What is the ratio of the Trade (in US$) in Puerto Rico in 1997 to that in 1998?
Your answer should be very brief. 0.93. What is the ratio of the Trade (in US$) of Euro area in 1997 to that in 1999?
Give a very brief answer. 0.92. What is the ratio of the Trade (in US$) in Chile in 1997 to that in 1999?
Provide a succinct answer. 1.21. What is the ratio of the Trade (in US$) in Nigeria in 1997 to that in 1999?
Ensure brevity in your answer.  1.59. What is the ratio of the Trade (in US$) in Puerto Rico in 1997 to that in 1999?
Your response must be concise. 0.79. What is the ratio of the Trade (in US$) in Euro area in 1997 to that in 2000?
Keep it short and to the point. 0.88. What is the ratio of the Trade (in US$) in Chile in 1997 to that in 2000?
Give a very brief answer. 1.07. What is the ratio of the Trade (in US$) in Nigeria in 1997 to that in 2000?
Your answer should be compact. 1.38. What is the ratio of the Trade (in US$) in Puerto Rico in 1997 to that in 2000?
Your response must be concise. 0.74. What is the ratio of the Trade (in US$) of Euro area in 1998 to that in 1999?
Provide a short and direct response. 0.97. What is the ratio of the Trade (in US$) in Chile in 1998 to that in 1999?
Keep it short and to the point. 1.18. What is the ratio of the Trade (in US$) of Nigeria in 1998 to that in 1999?
Your answer should be very brief. 1.48. What is the ratio of the Trade (in US$) of Puerto Rico in 1998 to that in 1999?
Provide a short and direct response. 0.85. What is the ratio of the Trade (in US$) of Euro area in 1998 to that in 2000?
Provide a short and direct response. 0.94. What is the ratio of the Trade (in US$) in Chile in 1998 to that in 2000?
Offer a very short reply. 1.04. What is the ratio of the Trade (in US$) of Nigeria in 1998 to that in 2000?
Provide a succinct answer. 1.28. What is the ratio of the Trade (in US$) of Puerto Rico in 1998 to that in 2000?
Your answer should be very brief. 0.79. What is the ratio of the Trade (in US$) in Euro area in 1999 to that in 2000?
Keep it short and to the point. 0.96. What is the ratio of the Trade (in US$) in Chile in 1999 to that in 2000?
Provide a short and direct response. 0.88. What is the ratio of the Trade (in US$) in Nigeria in 1999 to that in 2000?
Keep it short and to the point. 0.86. What is the ratio of the Trade (in US$) in Puerto Rico in 1999 to that in 2000?
Make the answer very short. 0.94. What is the difference between the highest and the second highest Trade (in US$) in Euro area?
Keep it short and to the point. 8.81e+1. What is the difference between the highest and the second highest Trade (in US$) in Chile?
Make the answer very short. 7.15e+08. What is the difference between the highest and the second highest Trade (in US$) in Nigeria?
Give a very brief answer. 8.93e+08. What is the difference between the highest and the second highest Trade (in US$) in Puerto Rico?
Give a very brief answer. 2.40e+09. What is the difference between the highest and the lowest Trade (in US$) of Euro area?
Provide a succinct answer. 6.12e+11. What is the difference between the highest and the lowest Trade (in US$) in Chile?
Ensure brevity in your answer.  9.53e+09. What is the difference between the highest and the lowest Trade (in US$) in Nigeria?
Ensure brevity in your answer.  9.31e+09. What is the difference between the highest and the lowest Trade (in US$) in Puerto Rico?
Your answer should be very brief. 1.48e+1. 